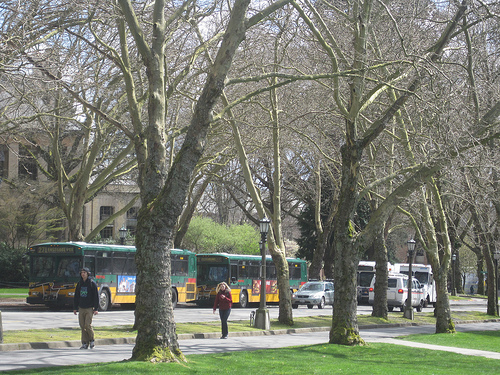How many people are on the sidewalk? Upon closer inspection, there are 2 individuals visible on the sidewalk, both seemingly enjoying a stroll amidst the tranquil environment marked by lush trees and a clear sky. 